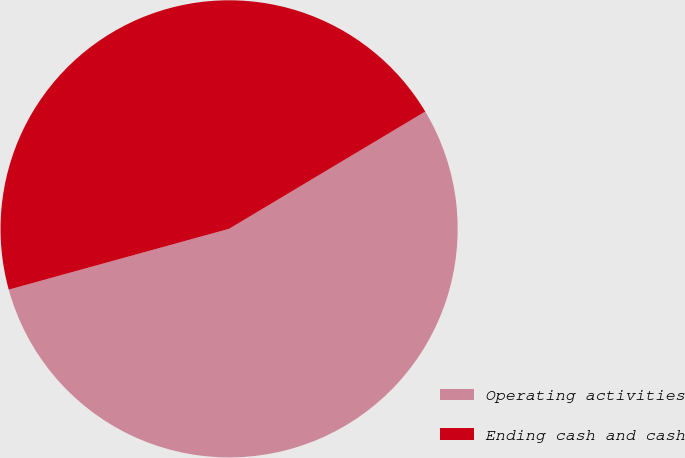<chart> <loc_0><loc_0><loc_500><loc_500><pie_chart><fcel>Operating activities<fcel>Ending cash and cash<nl><fcel>54.29%<fcel>45.71%<nl></chart> 